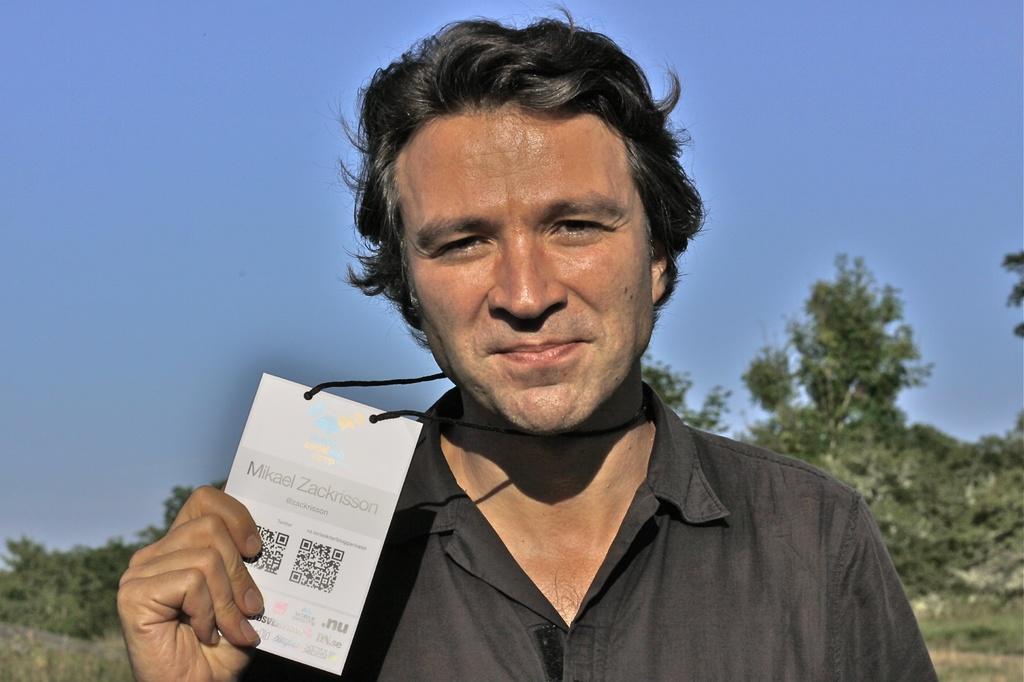In one or two sentences, can you explain what this image depicts? In this picture I can see a man is holding an object in the hand. The man is wearing black color shirt. In the background I can see sky and trees. 